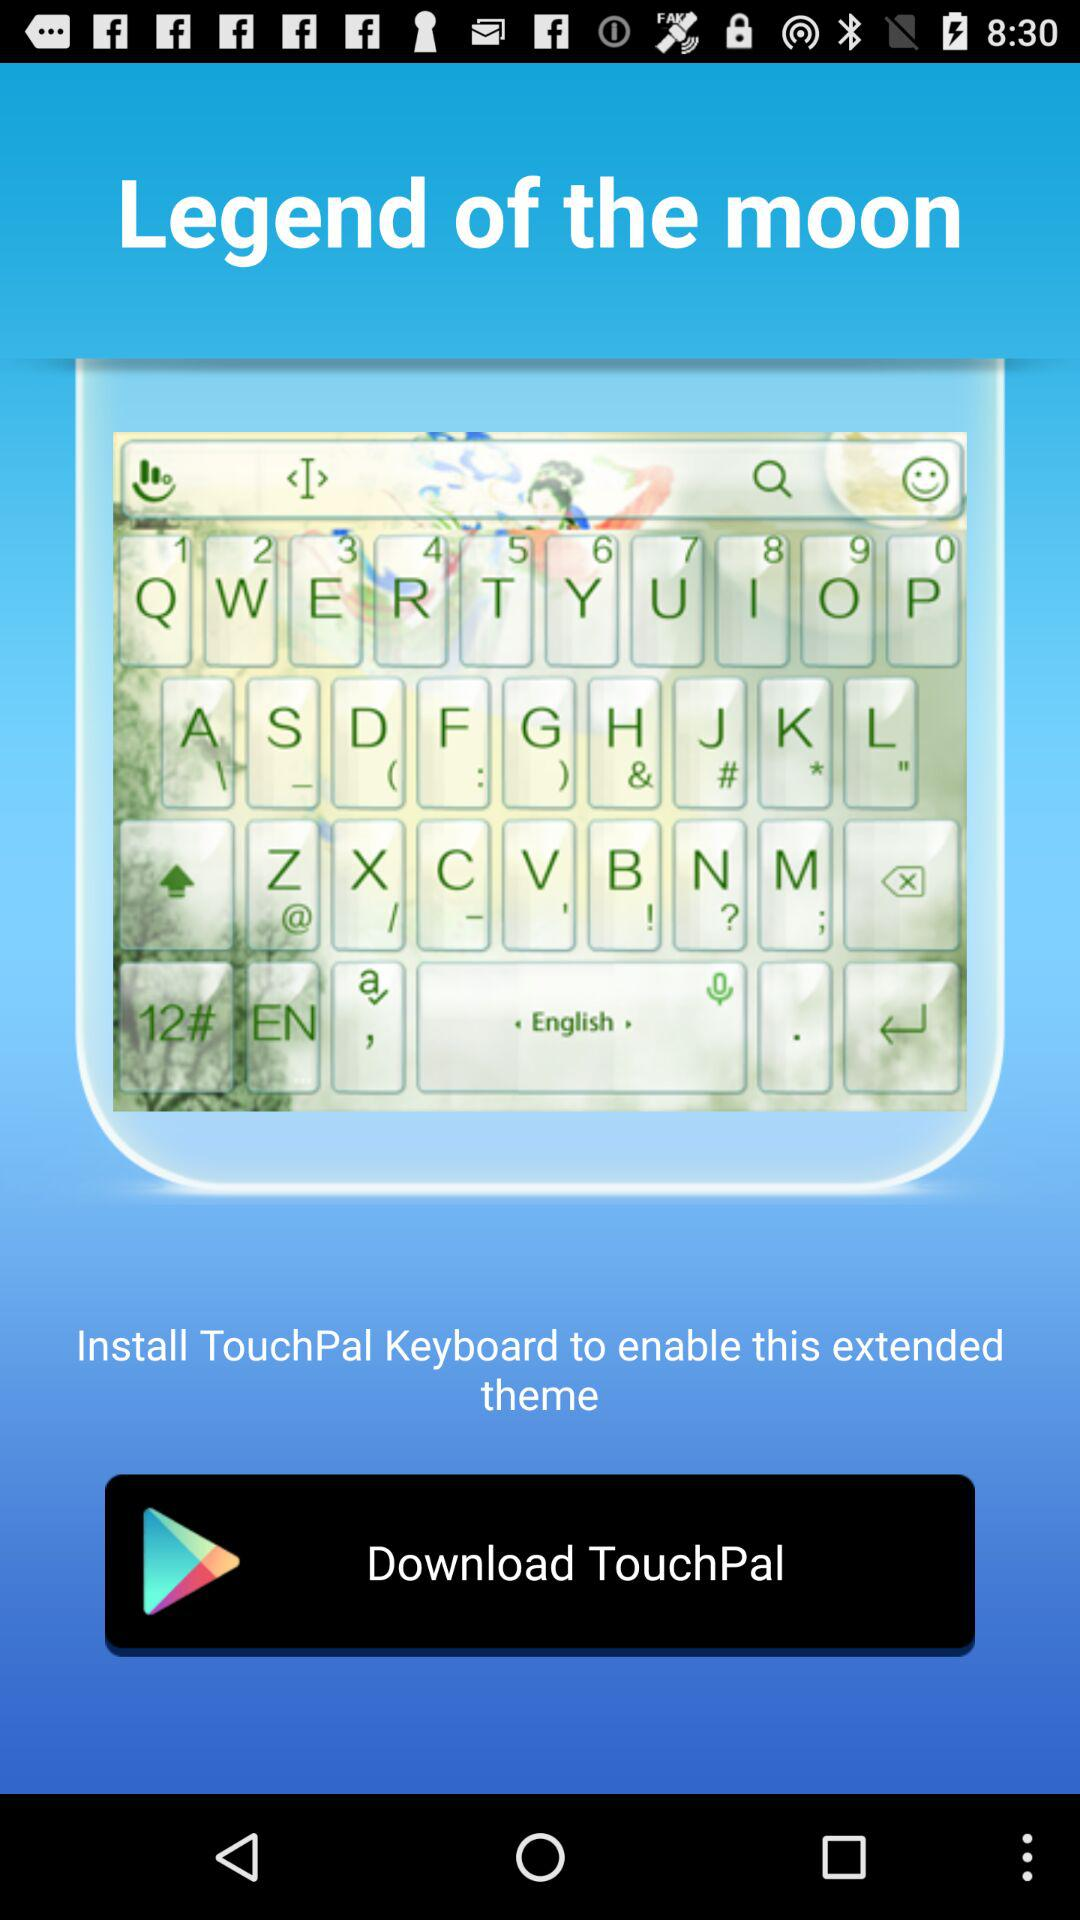What is the app name? The app name is "TouchPal". 